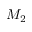<formula> <loc_0><loc_0><loc_500><loc_500>M _ { 2 }</formula> 